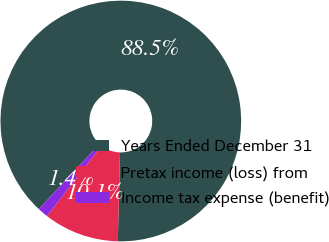<chart> <loc_0><loc_0><loc_500><loc_500><pie_chart><fcel>Years Ended December 31<fcel>Pretax income (loss) from<fcel>Income tax expense (benefit)<nl><fcel>88.47%<fcel>10.12%<fcel>1.41%<nl></chart> 